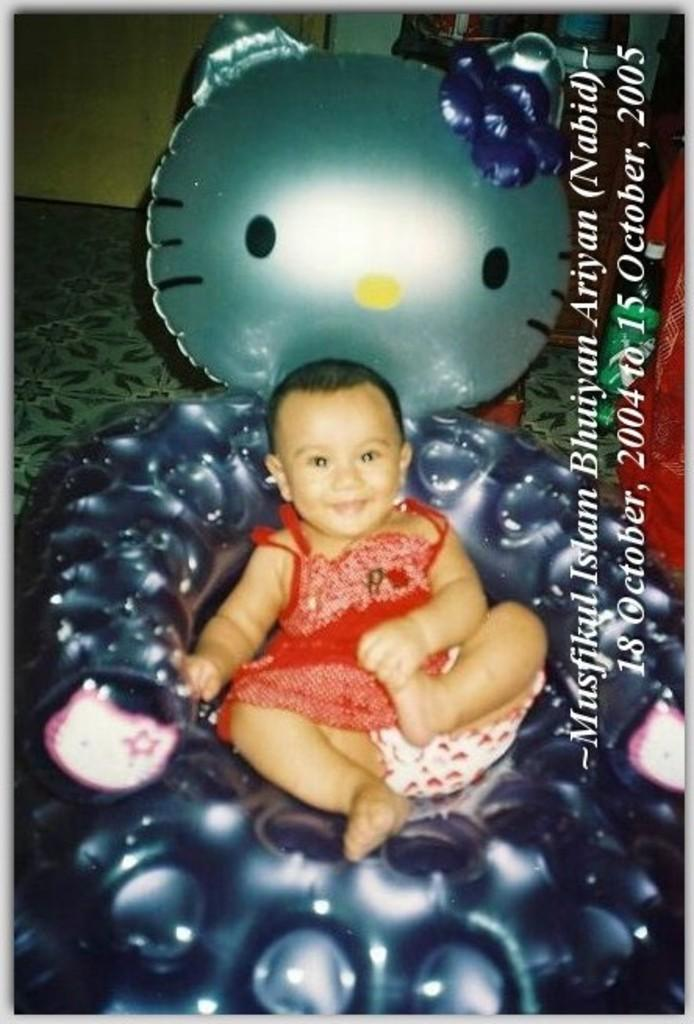What is the main subject of the image? There is a child in the image. What is the child's expression in the image? The child is smiling in the image. What is the child sitting on in the image? The child is sitting on a balloon chair in the image. What can be seen in the background of the image? There is a wall and objects in the background of the image. Is there any text present in the image? Yes, there is text in the image. In which direction is the child facing in the image? The provided facts do not specify the direction the child is facing in the image. What type of brush is being used by the child in the image? There is no brush present in the image. 